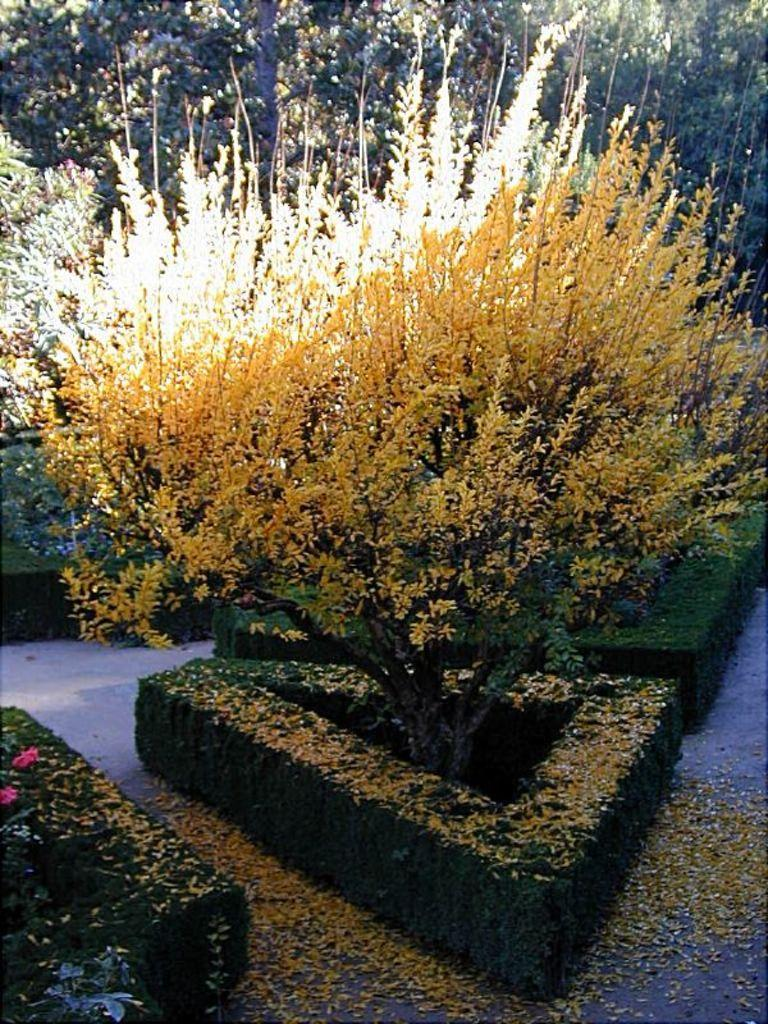What type of vegetation can be seen in the image? There are trees in the image. What other type of vegetation can be seen in the image? There are hedges in the image. Where are the trees and hedges located in the image? Both trees and hedges are on the ground in the image. What type of cable can be seen hanging from the trees in the image? There is no cable present in the image; only trees and hedges are visible. 